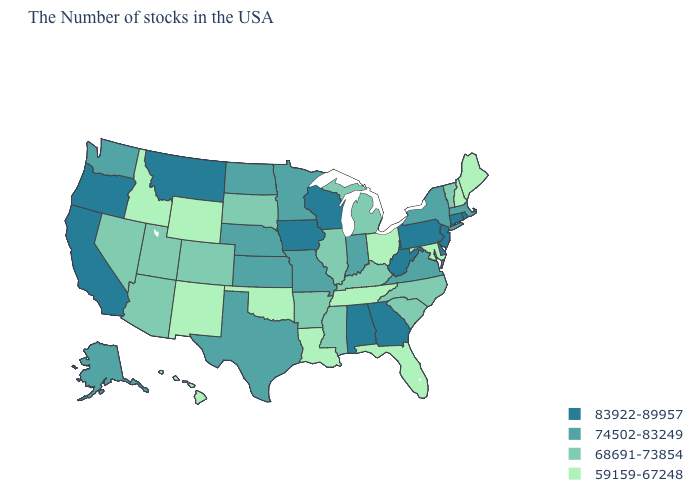What is the value of Florida?
Answer briefly. 59159-67248. What is the value of West Virginia?
Be succinct. 83922-89957. What is the value of New Mexico?
Keep it brief. 59159-67248. Name the states that have a value in the range 74502-83249?
Concise answer only. Massachusetts, New York, Virginia, Indiana, Missouri, Minnesota, Kansas, Nebraska, Texas, North Dakota, Washington, Alaska. Name the states that have a value in the range 74502-83249?
Answer briefly. Massachusetts, New York, Virginia, Indiana, Missouri, Minnesota, Kansas, Nebraska, Texas, North Dakota, Washington, Alaska. What is the value of Tennessee?
Keep it brief. 59159-67248. What is the value of Alaska?
Give a very brief answer. 74502-83249. Does California have the highest value in the USA?
Answer briefly. Yes. Does New Mexico have the lowest value in the West?
Give a very brief answer. Yes. Does the map have missing data?
Concise answer only. No. Which states have the lowest value in the USA?
Give a very brief answer. Maine, New Hampshire, Maryland, Ohio, Florida, Tennessee, Louisiana, Oklahoma, Wyoming, New Mexico, Idaho, Hawaii. Does Arkansas have a higher value than Nevada?
Answer briefly. No. Name the states that have a value in the range 74502-83249?
Give a very brief answer. Massachusetts, New York, Virginia, Indiana, Missouri, Minnesota, Kansas, Nebraska, Texas, North Dakota, Washington, Alaska. What is the highest value in the USA?
Keep it brief. 83922-89957. Name the states that have a value in the range 59159-67248?
Short answer required. Maine, New Hampshire, Maryland, Ohio, Florida, Tennessee, Louisiana, Oklahoma, Wyoming, New Mexico, Idaho, Hawaii. 